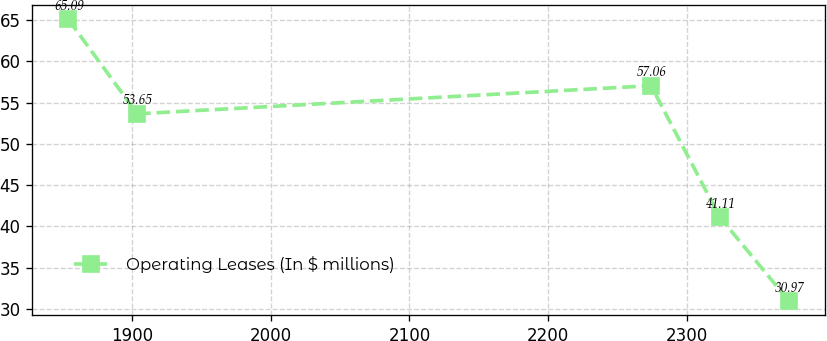Convert chart to OTSL. <chart><loc_0><loc_0><loc_500><loc_500><line_chart><ecel><fcel>Operating Leases (In $ millions)<nl><fcel>1854.17<fcel>65.09<nl><fcel>1903.8<fcel>53.65<nl><fcel>2274.09<fcel>57.06<nl><fcel>2323.72<fcel>41.11<nl><fcel>2373.35<fcel>30.97<nl></chart> 